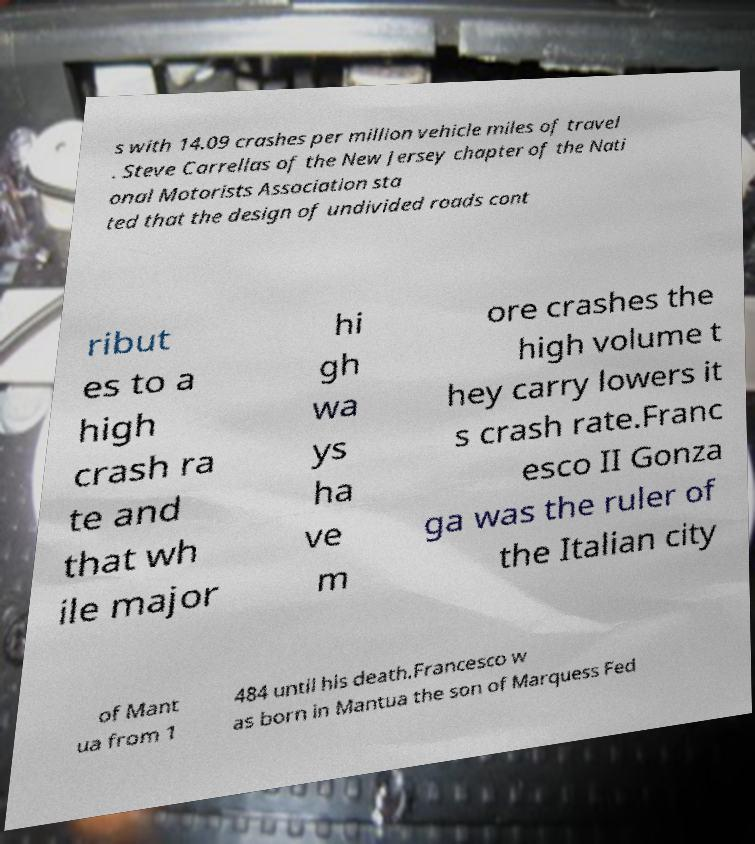For documentation purposes, I need the text within this image transcribed. Could you provide that? s with 14.09 crashes per million vehicle miles of travel . Steve Carrellas of the New Jersey chapter of the Nati onal Motorists Association sta ted that the design of undivided roads cont ribut es to a high crash ra te and that wh ile major hi gh wa ys ha ve m ore crashes the high volume t hey carry lowers it s crash rate.Franc esco II Gonza ga was the ruler of the Italian city of Mant ua from 1 484 until his death.Francesco w as born in Mantua the son of Marquess Fed 